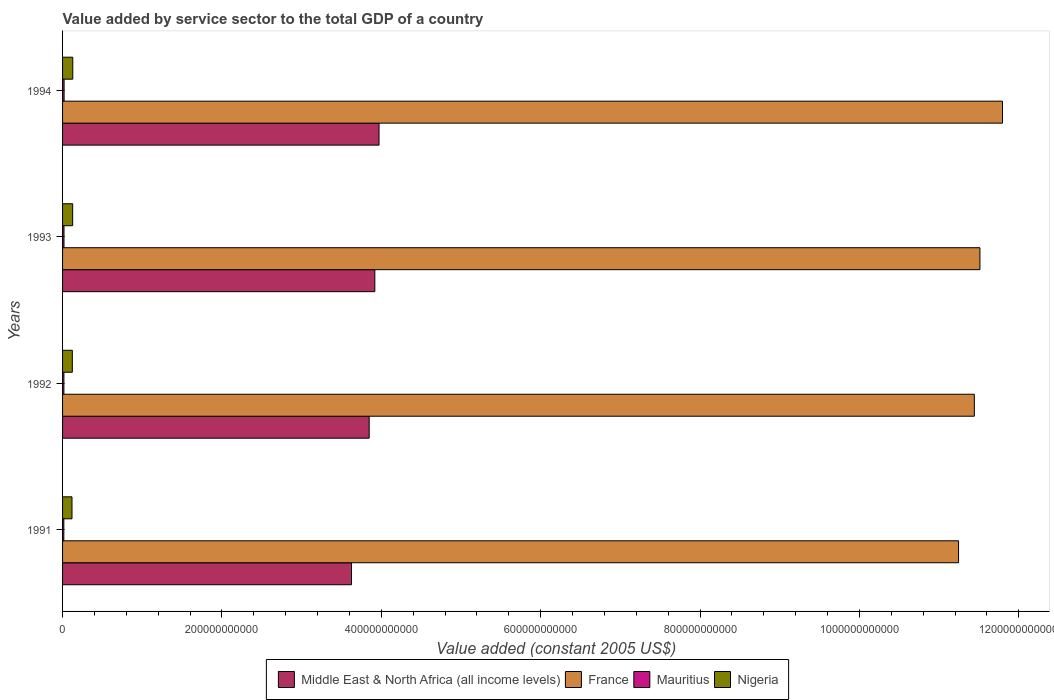How many different coloured bars are there?
Ensure brevity in your answer.  4. How many groups of bars are there?
Your response must be concise. 4. Are the number of bars per tick equal to the number of legend labels?
Make the answer very short. Yes. Are the number of bars on each tick of the Y-axis equal?
Your response must be concise. Yes. How many bars are there on the 2nd tick from the bottom?
Your response must be concise. 4. What is the label of the 3rd group of bars from the top?
Make the answer very short. 1992. What is the value added by service sector in Nigeria in 1994?
Your answer should be very brief. 1.28e+1. Across all years, what is the maximum value added by service sector in France?
Your answer should be very brief. 1.18e+12. Across all years, what is the minimum value added by service sector in Nigeria?
Your response must be concise. 1.18e+1. What is the total value added by service sector in France in the graph?
Give a very brief answer. 4.60e+12. What is the difference between the value added by service sector in Mauritius in 1992 and that in 1993?
Your response must be concise. -1.22e+08. What is the difference between the value added by service sector in Middle East & North Africa (all income levels) in 1994 and the value added by service sector in France in 1991?
Offer a terse response. -7.27e+11. What is the average value added by service sector in Middle East & North Africa (all income levels) per year?
Your response must be concise. 3.84e+11. In the year 1992, what is the difference between the value added by service sector in Nigeria and value added by service sector in Middle East & North Africa (all income levels)?
Keep it short and to the point. -3.73e+11. What is the ratio of the value added by service sector in Middle East & North Africa (all income levels) in 1992 to that in 1993?
Offer a terse response. 0.98. Is the value added by service sector in Mauritius in 1993 less than that in 1994?
Offer a terse response. Yes. What is the difference between the highest and the second highest value added by service sector in France?
Offer a terse response. 2.83e+1. What is the difference between the highest and the lowest value added by service sector in Mauritius?
Provide a short and direct response. 3.46e+08. In how many years, is the value added by service sector in France greater than the average value added by service sector in France taken over all years?
Offer a very short reply. 2. Is the sum of the value added by service sector in Nigeria in 1992 and 1993 greater than the maximum value added by service sector in Mauritius across all years?
Your response must be concise. Yes. Is it the case that in every year, the sum of the value added by service sector in France and value added by service sector in Mauritius is greater than the sum of value added by service sector in Middle East & North Africa (all income levels) and value added by service sector in Nigeria?
Keep it short and to the point. Yes. What does the 4th bar from the bottom in 1994 represents?
Your answer should be very brief. Nigeria. Is it the case that in every year, the sum of the value added by service sector in Nigeria and value added by service sector in France is greater than the value added by service sector in Mauritius?
Keep it short and to the point. Yes. How many years are there in the graph?
Your response must be concise. 4. What is the difference between two consecutive major ticks on the X-axis?
Provide a short and direct response. 2.00e+11. Are the values on the major ticks of X-axis written in scientific E-notation?
Offer a very short reply. No. Where does the legend appear in the graph?
Your answer should be very brief. Bottom center. How many legend labels are there?
Offer a terse response. 4. How are the legend labels stacked?
Your answer should be very brief. Horizontal. What is the title of the graph?
Provide a succinct answer. Value added by service sector to the total GDP of a country. Does "Iraq" appear as one of the legend labels in the graph?
Offer a very short reply. No. What is the label or title of the X-axis?
Make the answer very short. Value added (constant 2005 US$). What is the Value added (constant 2005 US$) of Middle East & North Africa (all income levels) in 1991?
Ensure brevity in your answer.  3.63e+11. What is the Value added (constant 2005 US$) in France in 1991?
Offer a very short reply. 1.12e+12. What is the Value added (constant 2005 US$) in Mauritius in 1991?
Provide a succinct answer. 1.58e+09. What is the Value added (constant 2005 US$) in Nigeria in 1991?
Your response must be concise. 1.18e+1. What is the Value added (constant 2005 US$) in Middle East & North Africa (all income levels) in 1992?
Give a very brief answer. 3.85e+11. What is the Value added (constant 2005 US$) in France in 1992?
Your answer should be compact. 1.14e+12. What is the Value added (constant 2005 US$) in Mauritius in 1992?
Provide a succinct answer. 1.68e+09. What is the Value added (constant 2005 US$) in Nigeria in 1992?
Offer a very short reply. 1.23e+1. What is the Value added (constant 2005 US$) of Middle East & North Africa (all income levels) in 1993?
Your response must be concise. 3.92e+11. What is the Value added (constant 2005 US$) of France in 1993?
Ensure brevity in your answer.  1.15e+12. What is the Value added (constant 2005 US$) of Mauritius in 1993?
Offer a very short reply. 1.81e+09. What is the Value added (constant 2005 US$) in Nigeria in 1993?
Your response must be concise. 1.27e+1. What is the Value added (constant 2005 US$) in Middle East & North Africa (all income levels) in 1994?
Your answer should be compact. 3.97e+11. What is the Value added (constant 2005 US$) of France in 1994?
Your answer should be very brief. 1.18e+12. What is the Value added (constant 2005 US$) of Mauritius in 1994?
Your response must be concise. 1.92e+09. What is the Value added (constant 2005 US$) of Nigeria in 1994?
Offer a terse response. 1.28e+1. Across all years, what is the maximum Value added (constant 2005 US$) of Middle East & North Africa (all income levels)?
Your answer should be compact. 3.97e+11. Across all years, what is the maximum Value added (constant 2005 US$) of France?
Provide a succinct answer. 1.18e+12. Across all years, what is the maximum Value added (constant 2005 US$) of Mauritius?
Your response must be concise. 1.92e+09. Across all years, what is the maximum Value added (constant 2005 US$) in Nigeria?
Ensure brevity in your answer.  1.28e+1. Across all years, what is the minimum Value added (constant 2005 US$) of Middle East & North Africa (all income levels)?
Offer a terse response. 3.63e+11. Across all years, what is the minimum Value added (constant 2005 US$) of France?
Provide a short and direct response. 1.12e+12. Across all years, what is the minimum Value added (constant 2005 US$) in Mauritius?
Provide a succinct answer. 1.58e+09. Across all years, what is the minimum Value added (constant 2005 US$) of Nigeria?
Provide a short and direct response. 1.18e+1. What is the total Value added (constant 2005 US$) of Middle East & North Africa (all income levels) in the graph?
Ensure brevity in your answer.  1.54e+12. What is the total Value added (constant 2005 US$) in France in the graph?
Provide a succinct answer. 4.60e+12. What is the total Value added (constant 2005 US$) in Mauritius in the graph?
Provide a succinct answer. 6.99e+09. What is the total Value added (constant 2005 US$) of Nigeria in the graph?
Provide a succinct answer. 4.96e+1. What is the difference between the Value added (constant 2005 US$) in Middle East & North Africa (all income levels) in 1991 and that in 1992?
Keep it short and to the point. -2.22e+1. What is the difference between the Value added (constant 2005 US$) in France in 1991 and that in 1992?
Offer a very short reply. -1.98e+1. What is the difference between the Value added (constant 2005 US$) of Mauritius in 1991 and that in 1992?
Offer a terse response. -1.07e+08. What is the difference between the Value added (constant 2005 US$) in Nigeria in 1991 and that in 1992?
Offer a very short reply. -4.15e+08. What is the difference between the Value added (constant 2005 US$) of Middle East & North Africa (all income levels) in 1991 and that in 1993?
Ensure brevity in your answer.  -2.93e+1. What is the difference between the Value added (constant 2005 US$) of France in 1991 and that in 1993?
Ensure brevity in your answer.  -2.68e+1. What is the difference between the Value added (constant 2005 US$) of Mauritius in 1991 and that in 1993?
Make the answer very short. -2.28e+08. What is the difference between the Value added (constant 2005 US$) of Nigeria in 1991 and that in 1993?
Your response must be concise. -8.36e+08. What is the difference between the Value added (constant 2005 US$) in Middle East & North Africa (all income levels) in 1991 and that in 1994?
Keep it short and to the point. -3.46e+1. What is the difference between the Value added (constant 2005 US$) in France in 1991 and that in 1994?
Offer a very short reply. -5.52e+1. What is the difference between the Value added (constant 2005 US$) in Mauritius in 1991 and that in 1994?
Your response must be concise. -3.46e+08. What is the difference between the Value added (constant 2005 US$) in Nigeria in 1991 and that in 1994?
Provide a short and direct response. -9.74e+08. What is the difference between the Value added (constant 2005 US$) of Middle East & North Africa (all income levels) in 1992 and that in 1993?
Offer a terse response. -7.07e+09. What is the difference between the Value added (constant 2005 US$) in France in 1992 and that in 1993?
Make the answer very short. -7.01e+09. What is the difference between the Value added (constant 2005 US$) in Mauritius in 1992 and that in 1993?
Make the answer very short. -1.22e+08. What is the difference between the Value added (constant 2005 US$) of Nigeria in 1992 and that in 1993?
Give a very brief answer. -4.20e+08. What is the difference between the Value added (constant 2005 US$) of Middle East & North Africa (all income levels) in 1992 and that in 1994?
Offer a terse response. -1.23e+1. What is the difference between the Value added (constant 2005 US$) in France in 1992 and that in 1994?
Your answer should be compact. -3.53e+1. What is the difference between the Value added (constant 2005 US$) in Mauritius in 1992 and that in 1994?
Offer a terse response. -2.39e+08. What is the difference between the Value added (constant 2005 US$) in Nigeria in 1992 and that in 1994?
Provide a short and direct response. -5.59e+08. What is the difference between the Value added (constant 2005 US$) of Middle East & North Africa (all income levels) in 1993 and that in 1994?
Ensure brevity in your answer.  -5.27e+09. What is the difference between the Value added (constant 2005 US$) in France in 1993 and that in 1994?
Keep it short and to the point. -2.83e+1. What is the difference between the Value added (constant 2005 US$) in Mauritius in 1993 and that in 1994?
Make the answer very short. -1.17e+08. What is the difference between the Value added (constant 2005 US$) of Nigeria in 1993 and that in 1994?
Keep it short and to the point. -1.39e+08. What is the difference between the Value added (constant 2005 US$) of Middle East & North Africa (all income levels) in 1991 and the Value added (constant 2005 US$) of France in 1992?
Give a very brief answer. -7.82e+11. What is the difference between the Value added (constant 2005 US$) of Middle East & North Africa (all income levels) in 1991 and the Value added (constant 2005 US$) of Mauritius in 1992?
Your answer should be compact. 3.61e+11. What is the difference between the Value added (constant 2005 US$) of Middle East & North Africa (all income levels) in 1991 and the Value added (constant 2005 US$) of Nigeria in 1992?
Provide a short and direct response. 3.50e+11. What is the difference between the Value added (constant 2005 US$) in France in 1991 and the Value added (constant 2005 US$) in Mauritius in 1992?
Offer a terse response. 1.12e+12. What is the difference between the Value added (constant 2005 US$) in France in 1991 and the Value added (constant 2005 US$) in Nigeria in 1992?
Ensure brevity in your answer.  1.11e+12. What is the difference between the Value added (constant 2005 US$) of Mauritius in 1991 and the Value added (constant 2005 US$) of Nigeria in 1992?
Provide a succinct answer. -1.07e+1. What is the difference between the Value added (constant 2005 US$) of Middle East & North Africa (all income levels) in 1991 and the Value added (constant 2005 US$) of France in 1993?
Your answer should be compact. -7.89e+11. What is the difference between the Value added (constant 2005 US$) of Middle East & North Africa (all income levels) in 1991 and the Value added (constant 2005 US$) of Mauritius in 1993?
Provide a short and direct response. 3.61e+11. What is the difference between the Value added (constant 2005 US$) of Middle East & North Africa (all income levels) in 1991 and the Value added (constant 2005 US$) of Nigeria in 1993?
Your answer should be very brief. 3.50e+11. What is the difference between the Value added (constant 2005 US$) in France in 1991 and the Value added (constant 2005 US$) in Mauritius in 1993?
Your answer should be very brief. 1.12e+12. What is the difference between the Value added (constant 2005 US$) in France in 1991 and the Value added (constant 2005 US$) in Nigeria in 1993?
Ensure brevity in your answer.  1.11e+12. What is the difference between the Value added (constant 2005 US$) of Mauritius in 1991 and the Value added (constant 2005 US$) of Nigeria in 1993?
Offer a terse response. -1.11e+1. What is the difference between the Value added (constant 2005 US$) of Middle East & North Africa (all income levels) in 1991 and the Value added (constant 2005 US$) of France in 1994?
Offer a very short reply. -8.17e+11. What is the difference between the Value added (constant 2005 US$) in Middle East & North Africa (all income levels) in 1991 and the Value added (constant 2005 US$) in Mauritius in 1994?
Provide a short and direct response. 3.61e+11. What is the difference between the Value added (constant 2005 US$) of Middle East & North Africa (all income levels) in 1991 and the Value added (constant 2005 US$) of Nigeria in 1994?
Offer a terse response. 3.50e+11. What is the difference between the Value added (constant 2005 US$) of France in 1991 and the Value added (constant 2005 US$) of Mauritius in 1994?
Make the answer very short. 1.12e+12. What is the difference between the Value added (constant 2005 US$) in France in 1991 and the Value added (constant 2005 US$) in Nigeria in 1994?
Make the answer very short. 1.11e+12. What is the difference between the Value added (constant 2005 US$) of Mauritius in 1991 and the Value added (constant 2005 US$) of Nigeria in 1994?
Make the answer very short. -1.12e+1. What is the difference between the Value added (constant 2005 US$) in Middle East & North Africa (all income levels) in 1992 and the Value added (constant 2005 US$) in France in 1993?
Give a very brief answer. -7.66e+11. What is the difference between the Value added (constant 2005 US$) in Middle East & North Africa (all income levels) in 1992 and the Value added (constant 2005 US$) in Mauritius in 1993?
Ensure brevity in your answer.  3.83e+11. What is the difference between the Value added (constant 2005 US$) in Middle East & North Africa (all income levels) in 1992 and the Value added (constant 2005 US$) in Nigeria in 1993?
Offer a very short reply. 3.72e+11. What is the difference between the Value added (constant 2005 US$) in France in 1992 and the Value added (constant 2005 US$) in Mauritius in 1993?
Keep it short and to the point. 1.14e+12. What is the difference between the Value added (constant 2005 US$) of France in 1992 and the Value added (constant 2005 US$) of Nigeria in 1993?
Make the answer very short. 1.13e+12. What is the difference between the Value added (constant 2005 US$) of Mauritius in 1992 and the Value added (constant 2005 US$) of Nigeria in 1993?
Your answer should be compact. -1.10e+1. What is the difference between the Value added (constant 2005 US$) of Middle East & North Africa (all income levels) in 1992 and the Value added (constant 2005 US$) of France in 1994?
Your answer should be compact. -7.95e+11. What is the difference between the Value added (constant 2005 US$) of Middle East & North Africa (all income levels) in 1992 and the Value added (constant 2005 US$) of Mauritius in 1994?
Give a very brief answer. 3.83e+11. What is the difference between the Value added (constant 2005 US$) in Middle East & North Africa (all income levels) in 1992 and the Value added (constant 2005 US$) in Nigeria in 1994?
Your answer should be compact. 3.72e+11. What is the difference between the Value added (constant 2005 US$) of France in 1992 and the Value added (constant 2005 US$) of Mauritius in 1994?
Give a very brief answer. 1.14e+12. What is the difference between the Value added (constant 2005 US$) in France in 1992 and the Value added (constant 2005 US$) in Nigeria in 1994?
Offer a very short reply. 1.13e+12. What is the difference between the Value added (constant 2005 US$) in Mauritius in 1992 and the Value added (constant 2005 US$) in Nigeria in 1994?
Offer a terse response. -1.11e+1. What is the difference between the Value added (constant 2005 US$) of Middle East & North Africa (all income levels) in 1993 and the Value added (constant 2005 US$) of France in 1994?
Offer a very short reply. -7.88e+11. What is the difference between the Value added (constant 2005 US$) in Middle East & North Africa (all income levels) in 1993 and the Value added (constant 2005 US$) in Mauritius in 1994?
Your answer should be very brief. 3.90e+11. What is the difference between the Value added (constant 2005 US$) of Middle East & North Africa (all income levels) in 1993 and the Value added (constant 2005 US$) of Nigeria in 1994?
Provide a short and direct response. 3.79e+11. What is the difference between the Value added (constant 2005 US$) in France in 1993 and the Value added (constant 2005 US$) in Mauritius in 1994?
Make the answer very short. 1.15e+12. What is the difference between the Value added (constant 2005 US$) of France in 1993 and the Value added (constant 2005 US$) of Nigeria in 1994?
Offer a terse response. 1.14e+12. What is the difference between the Value added (constant 2005 US$) of Mauritius in 1993 and the Value added (constant 2005 US$) of Nigeria in 1994?
Keep it short and to the point. -1.10e+1. What is the average Value added (constant 2005 US$) in Middle East & North Africa (all income levels) per year?
Keep it short and to the point. 3.84e+11. What is the average Value added (constant 2005 US$) of France per year?
Offer a terse response. 1.15e+12. What is the average Value added (constant 2005 US$) in Mauritius per year?
Keep it short and to the point. 1.75e+09. What is the average Value added (constant 2005 US$) of Nigeria per year?
Ensure brevity in your answer.  1.24e+1. In the year 1991, what is the difference between the Value added (constant 2005 US$) in Middle East & North Africa (all income levels) and Value added (constant 2005 US$) in France?
Offer a very short reply. -7.62e+11. In the year 1991, what is the difference between the Value added (constant 2005 US$) of Middle East & North Africa (all income levels) and Value added (constant 2005 US$) of Mauritius?
Provide a short and direct response. 3.61e+11. In the year 1991, what is the difference between the Value added (constant 2005 US$) of Middle East & North Africa (all income levels) and Value added (constant 2005 US$) of Nigeria?
Give a very brief answer. 3.51e+11. In the year 1991, what is the difference between the Value added (constant 2005 US$) in France and Value added (constant 2005 US$) in Mauritius?
Make the answer very short. 1.12e+12. In the year 1991, what is the difference between the Value added (constant 2005 US$) of France and Value added (constant 2005 US$) of Nigeria?
Make the answer very short. 1.11e+12. In the year 1991, what is the difference between the Value added (constant 2005 US$) in Mauritius and Value added (constant 2005 US$) in Nigeria?
Your response must be concise. -1.03e+1. In the year 1992, what is the difference between the Value added (constant 2005 US$) in Middle East & North Africa (all income levels) and Value added (constant 2005 US$) in France?
Make the answer very short. -7.59e+11. In the year 1992, what is the difference between the Value added (constant 2005 US$) in Middle East & North Africa (all income levels) and Value added (constant 2005 US$) in Mauritius?
Your answer should be compact. 3.83e+11. In the year 1992, what is the difference between the Value added (constant 2005 US$) in Middle East & North Africa (all income levels) and Value added (constant 2005 US$) in Nigeria?
Your answer should be compact. 3.73e+11. In the year 1992, what is the difference between the Value added (constant 2005 US$) of France and Value added (constant 2005 US$) of Mauritius?
Provide a short and direct response. 1.14e+12. In the year 1992, what is the difference between the Value added (constant 2005 US$) of France and Value added (constant 2005 US$) of Nigeria?
Make the answer very short. 1.13e+12. In the year 1992, what is the difference between the Value added (constant 2005 US$) in Mauritius and Value added (constant 2005 US$) in Nigeria?
Your answer should be very brief. -1.06e+1. In the year 1993, what is the difference between the Value added (constant 2005 US$) of Middle East & North Africa (all income levels) and Value added (constant 2005 US$) of France?
Keep it short and to the point. -7.59e+11. In the year 1993, what is the difference between the Value added (constant 2005 US$) in Middle East & North Africa (all income levels) and Value added (constant 2005 US$) in Mauritius?
Offer a very short reply. 3.90e+11. In the year 1993, what is the difference between the Value added (constant 2005 US$) in Middle East & North Africa (all income levels) and Value added (constant 2005 US$) in Nigeria?
Provide a short and direct response. 3.79e+11. In the year 1993, what is the difference between the Value added (constant 2005 US$) of France and Value added (constant 2005 US$) of Mauritius?
Keep it short and to the point. 1.15e+12. In the year 1993, what is the difference between the Value added (constant 2005 US$) of France and Value added (constant 2005 US$) of Nigeria?
Your response must be concise. 1.14e+12. In the year 1993, what is the difference between the Value added (constant 2005 US$) in Mauritius and Value added (constant 2005 US$) in Nigeria?
Your response must be concise. -1.09e+1. In the year 1994, what is the difference between the Value added (constant 2005 US$) in Middle East & North Africa (all income levels) and Value added (constant 2005 US$) in France?
Provide a succinct answer. -7.82e+11. In the year 1994, what is the difference between the Value added (constant 2005 US$) of Middle East & North Africa (all income levels) and Value added (constant 2005 US$) of Mauritius?
Provide a succinct answer. 3.95e+11. In the year 1994, what is the difference between the Value added (constant 2005 US$) in Middle East & North Africa (all income levels) and Value added (constant 2005 US$) in Nigeria?
Keep it short and to the point. 3.84e+11. In the year 1994, what is the difference between the Value added (constant 2005 US$) of France and Value added (constant 2005 US$) of Mauritius?
Offer a very short reply. 1.18e+12. In the year 1994, what is the difference between the Value added (constant 2005 US$) in France and Value added (constant 2005 US$) in Nigeria?
Keep it short and to the point. 1.17e+12. In the year 1994, what is the difference between the Value added (constant 2005 US$) of Mauritius and Value added (constant 2005 US$) of Nigeria?
Make the answer very short. -1.09e+1. What is the ratio of the Value added (constant 2005 US$) of Middle East & North Africa (all income levels) in 1991 to that in 1992?
Make the answer very short. 0.94. What is the ratio of the Value added (constant 2005 US$) in France in 1991 to that in 1992?
Offer a very short reply. 0.98. What is the ratio of the Value added (constant 2005 US$) in Mauritius in 1991 to that in 1992?
Provide a succinct answer. 0.94. What is the ratio of the Value added (constant 2005 US$) of Nigeria in 1991 to that in 1992?
Provide a short and direct response. 0.97. What is the ratio of the Value added (constant 2005 US$) in Middle East & North Africa (all income levels) in 1991 to that in 1993?
Keep it short and to the point. 0.93. What is the ratio of the Value added (constant 2005 US$) of France in 1991 to that in 1993?
Your answer should be compact. 0.98. What is the ratio of the Value added (constant 2005 US$) in Mauritius in 1991 to that in 1993?
Your answer should be compact. 0.87. What is the ratio of the Value added (constant 2005 US$) of Nigeria in 1991 to that in 1993?
Keep it short and to the point. 0.93. What is the ratio of the Value added (constant 2005 US$) of France in 1991 to that in 1994?
Ensure brevity in your answer.  0.95. What is the ratio of the Value added (constant 2005 US$) of Mauritius in 1991 to that in 1994?
Keep it short and to the point. 0.82. What is the ratio of the Value added (constant 2005 US$) in Nigeria in 1991 to that in 1994?
Your answer should be very brief. 0.92. What is the ratio of the Value added (constant 2005 US$) of Middle East & North Africa (all income levels) in 1992 to that in 1993?
Offer a very short reply. 0.98. What is the ratio of the Value added (constant 2005 US$) of Mauritius in 1992 to that in 1993?
Keep it short and to the point. 0.93. What is the ratio of the Value added (constant 2005 US$) of Nigeria in 1992 to that in 1993?
Offer a terse response. 0.97. What is the ratio of the Value added (constant 2005 US$) in Middle East & North Africa (all income levels) in 1992 to that in 1994?
Make the answer very short. 0.97. What is the ratio of the Value added (constant 2005 US$) of France in 1992 to that in 1994?
Your answer should be very brief. 0.97. What is the ratio of the Value added (constant 2005 US$) of Mauritius in 1992 to that in 1994?
Keep it short and to the point. 0.88. What is the ratio of the Value added (constant 2005 US$) of Nigeria in 1992 to that in 1994?
Provide a succinct answer. 0.96. What is the ratio of the Value added (constant 2005 US$) in Middle East & North Africa (all income levels) in 1993 to that in 1994?
Make the answer very short. 0.99. What is the ratio of the Value added (constant 2005 US$) in France in 1993 to that in 1994?
Offer a very short reply. 0.98. What is the ratio of the Value added (constant 2005 US$) of Mauritius in 1993 to that in 1994?
Your answer should be compact. 0.94. What is the ratio of the Value added (constant 2005 US$) in Nigeria in 1993 to that in 1994?
Provide a succinct answer. 0.99. What is the difference between the highest and the second highest Value added (constant 2005 US$) of Middle East & North Africa (all income levels)?
Ensure brevity in your answer.  5.27e+09. What is the difference between the highest and the second highest Value added (constant 2005 US$) in France?
Make the answer very short. 2.83e+1. What is the difference between the highest and the second highest Value added (constant 2005 US$) in Mauritius?
Your response must be concise. 1.17e+08. What is the difference between the highest and the second highest Value added (constant 2005 US$) of Nigeria?
Offer a very short reply. 1.39e+08. What is the difference between the highest and the lowest Value added (constant 2005 US$) of Middle East & North Africa (all income levels)?
Give a very brief answer. 3.46e+1. What is the difference between the highest and the lowest Value added (constant 2005 US$) in France?
Make the answer very short. 5.52e+1. What is the difference between the highest and the lowest Value added (constant 2005 US$) in Mauritius?
Provide a succinct answer. 3.46e+08. What is the difference between the highest and the lowest Value added (constant 2005 US$) of Nigeria?
Keep it short and to the point. 9.74e+08. 